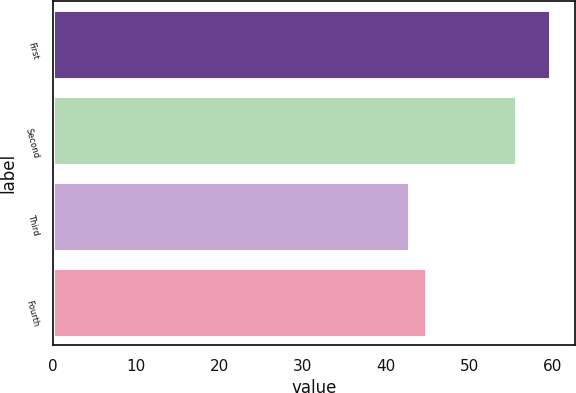Convert chart. <chart><loc_0><loc_0><loc_500><loc_500><bar_chart><fcel>First<fcel>Second<fcel>Third<fcel>Fourth<nl><fcel>59.67<fcel>55.56<fcel>42.7<fcel>44.74<nl></chart> 